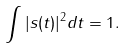<formula> <loc_0><loc_0><loc_500><loc_500>\int | s ( t ) | ^ { 2 } d t = 1 .</formula> 